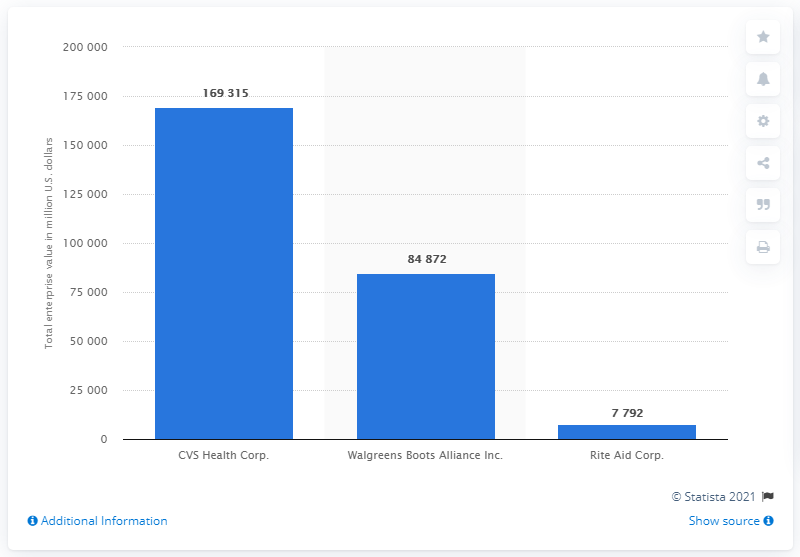Highlight a few significant elements in this photo. At the end of 2021, Rite Aid Corp.'s value was 7,792. 